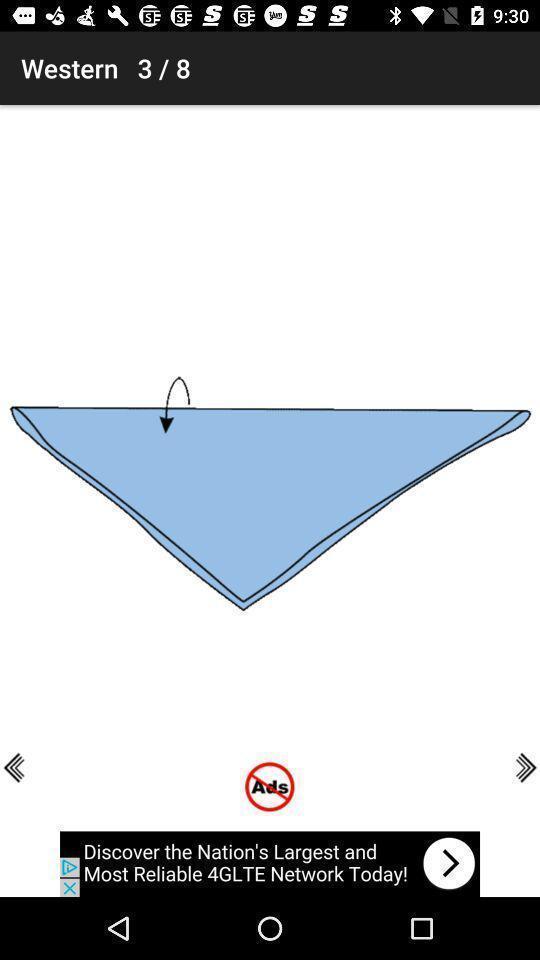Explain what's happening in this screen capture. Page showing guidance for scarf tying. 